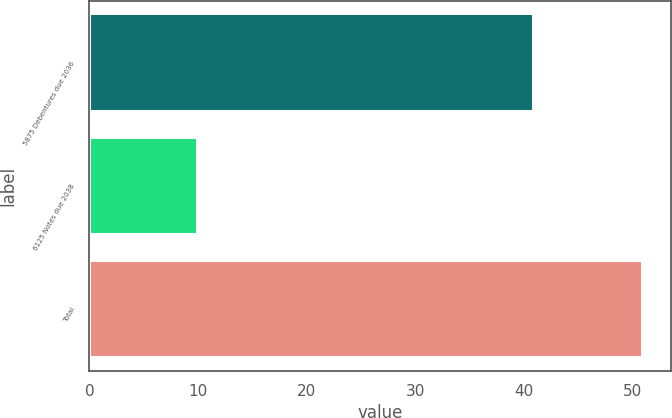Convert chart to OTSL. <chart><loc_0><loc_0><loc_500><loc_500><bar_chart><fcel>5875 Debentures due 2036<fcel>6125 Notes due 2038<fcel>Total<nl><fcel>41<fcel>10<fcel>51<nl></chart> 